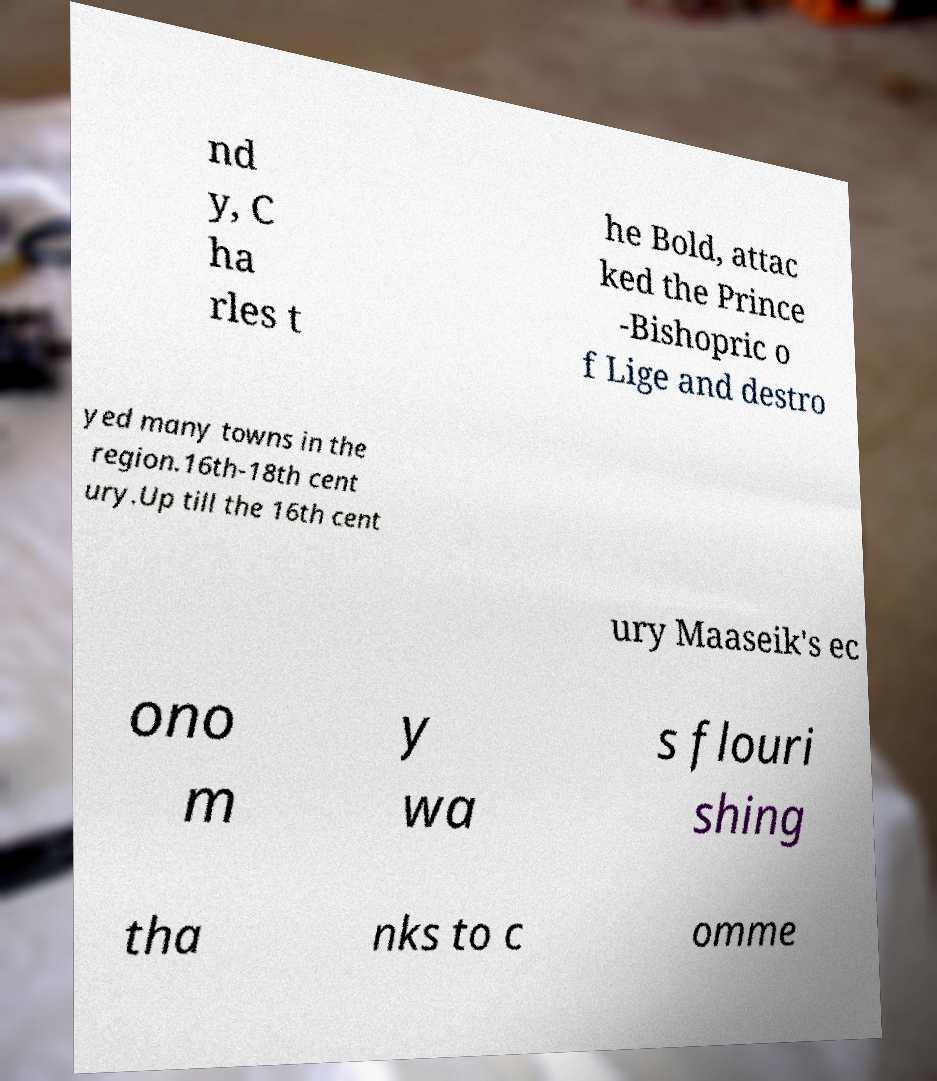What messages or text are displayed in this image? I need them in a readable, typed format. nd y, C ha rles t he Bold, attac ked the Prince -Bishopric o f Lige and destro yed many towns in the region.16th-18th cent ury.Up till the 16th cent ury Maaseik's ec ono m y wa s flouri shing tha nks to c omme 